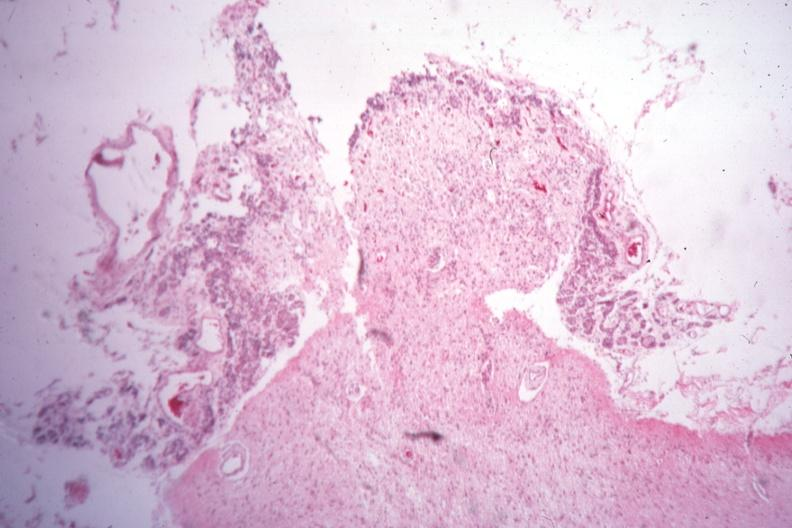was sella empty case of type i diabetes with pituitectomy for retinal lesions 9 years?
Answer the question using a single word or phrase. Yes 